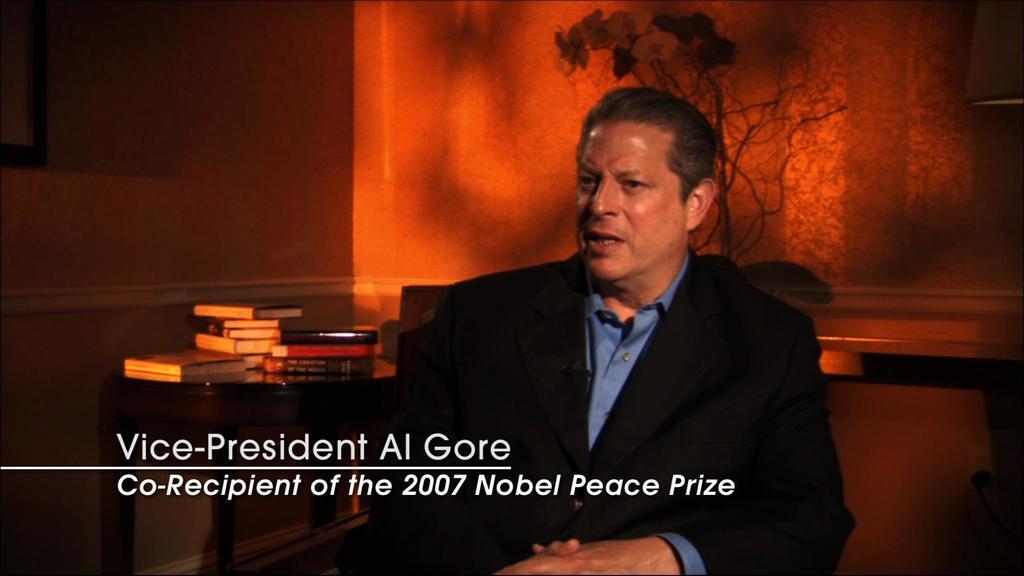Please provide a concise description of this image. We can see a man is sitting on a chair. On the left side there are books on a table, frame on the wall and in the background there is a plant with flowers and at the bottom there are texts written on the image. 